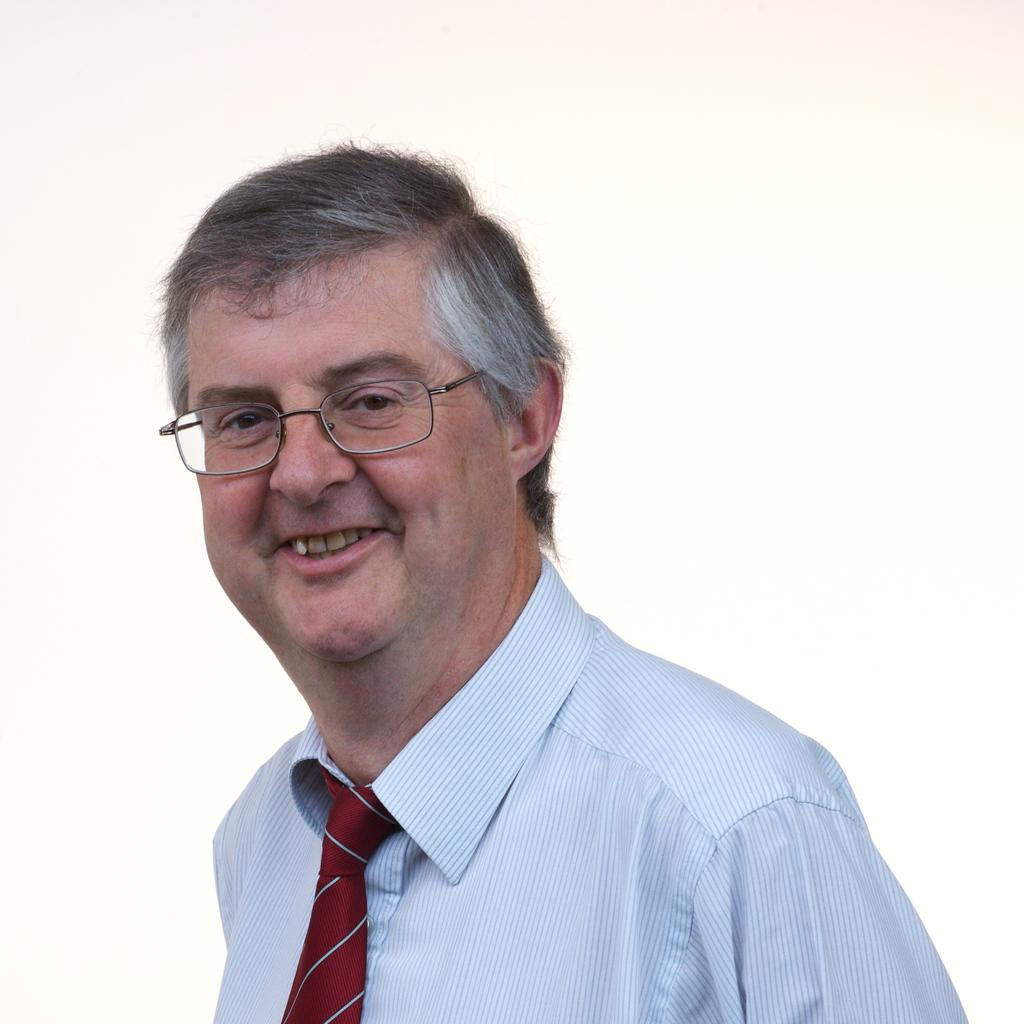Who is the main subject in the image? There is a man in the image. Where is the man located in the image? The man is located towards the bottom of the image. What is the man wearing in the image? The man is wearing a shirt, a tie, and spectacles. What is the color of the background in the image? The background of the image is white in color. What type of police vehicle can be seen in the image? There is no police vehicle present in the image. Where is the shade located in the image? There is no shade present in the image. What type of playground equipment can be seen in the image? There is no playground equipment present in the image. 